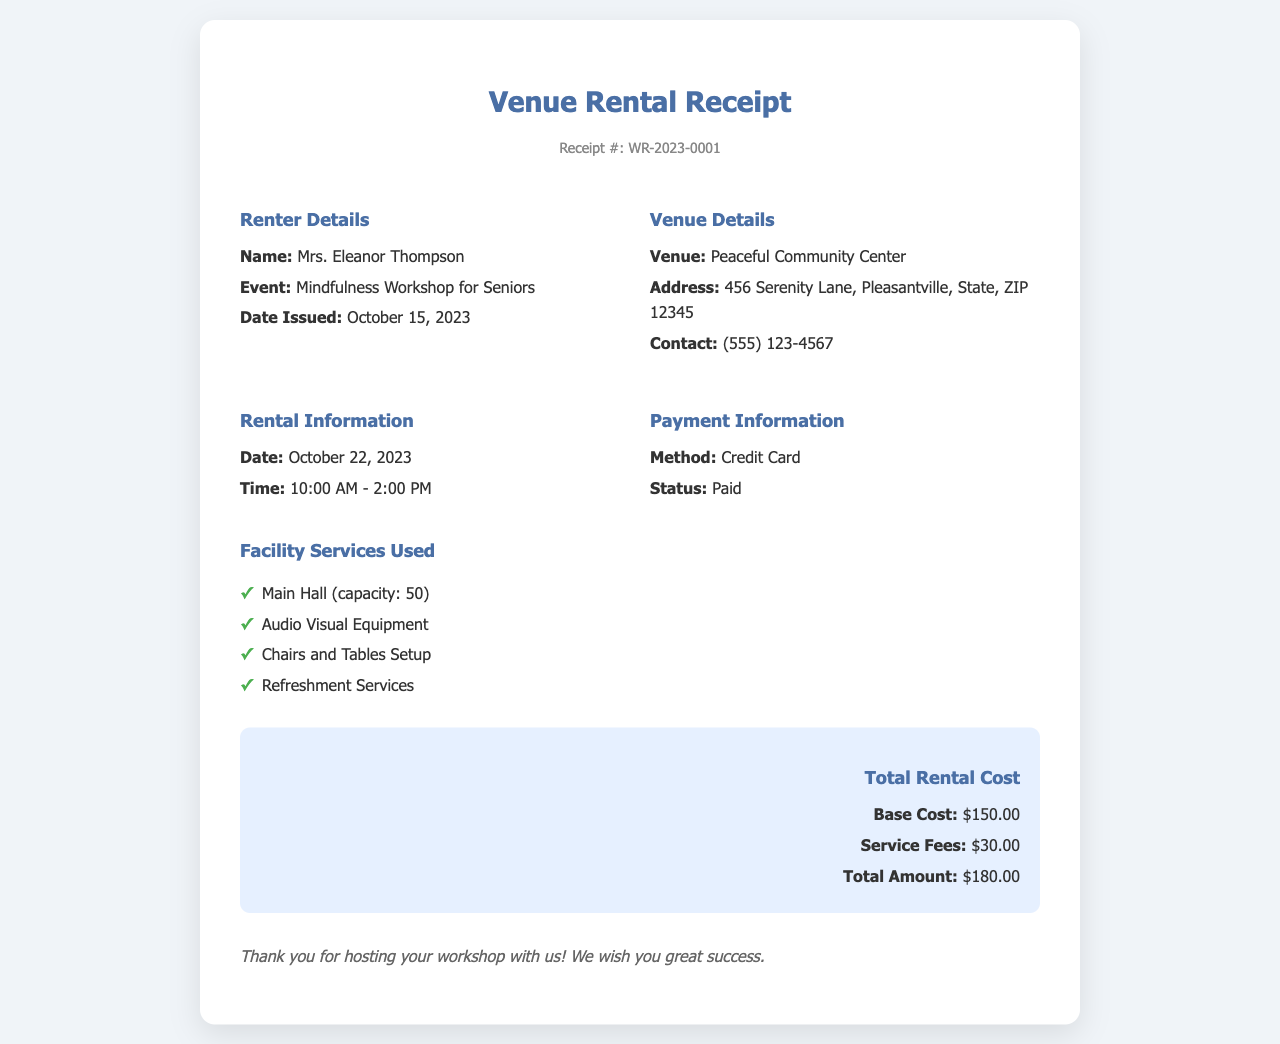What is the receipt number? The receipt number is indicated at the top of the document under "Receipt #."
Answer: WR-2023-0001 Who is the renter? The renter's name is mentioned in the "Renter Details" section.
Answer: Mrs. Eleanor Thompson What is the date of the workshop? The date is specified in the "Rental Information" section.
Answer: October 22, 2023 What facility services were used? The services used are listed under "Facility Services Used" in the document.
Answer: Main Hall, Audio Visual Equipment, Chairs and Tables Setup, Refreshment Services What is the total rental cost? The total rental cost can be found in the "Total Rental Cost" section of the document.
Answer: $180.00 What time does the workshop start? The starting time of the workshop is provided in the "Rental Information" section.
Answer: 10:00 AM What is the payment status? The payment status can be found in the "Payment Information" section of the document.
Answer: Paid What is the base cost for the venue? The base cost is specified in the "Total Rental Cost" section.
Answer: $150.00 Where is the venue located? The venue's address is detailed in the "Venue Details" section.
Answer: 456 Serenity Lane, Pleasantville, State, ZIP 12345 